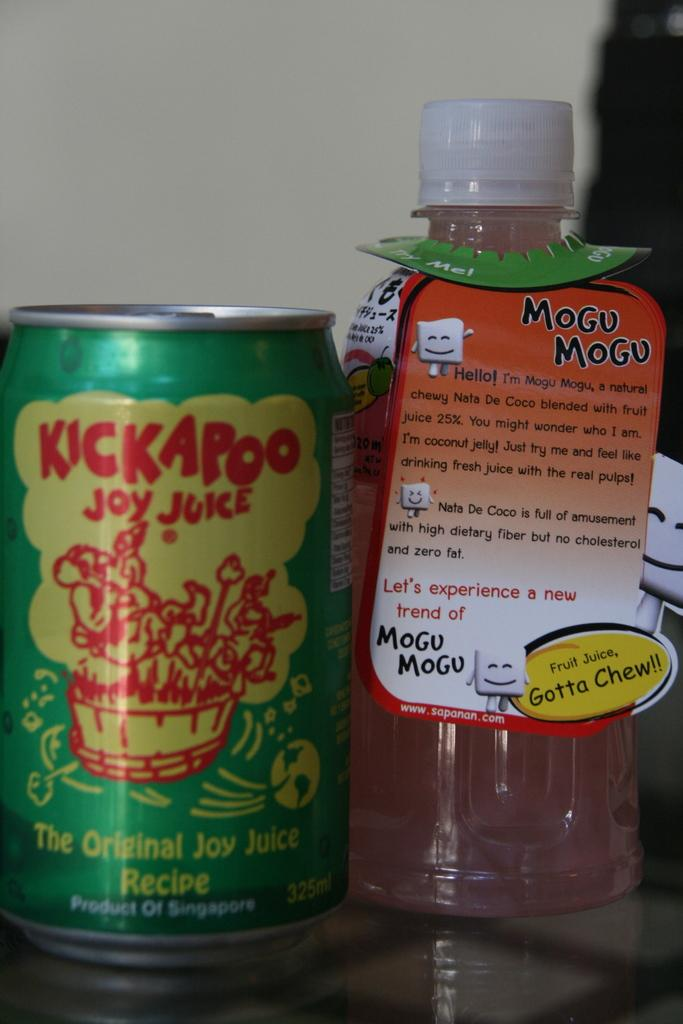<image>
Write a terse but informative summary of the picture. a bottle of mogu mogu next to a can of kickapoo joy juice 